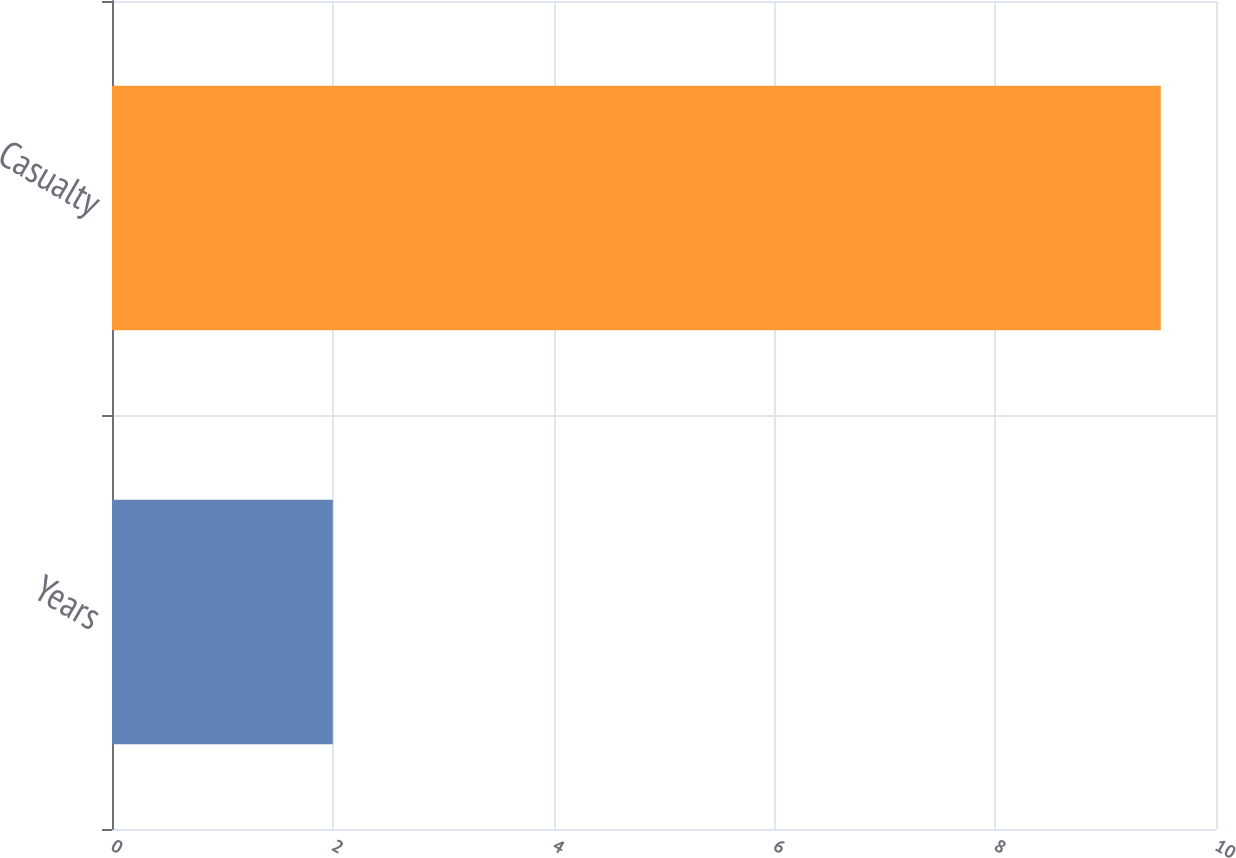Convert chart to OTSL. <chart><loc_0><loc_0><loc_500><loc_500><bar_chart><fcel>Years<fcel>Casualty<nl><fcel>2<fcel>9.5<nl></chart> 